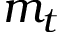<formula> <loc_0><loc_0><loc_500><loc_500>m _ { t }</formula> 